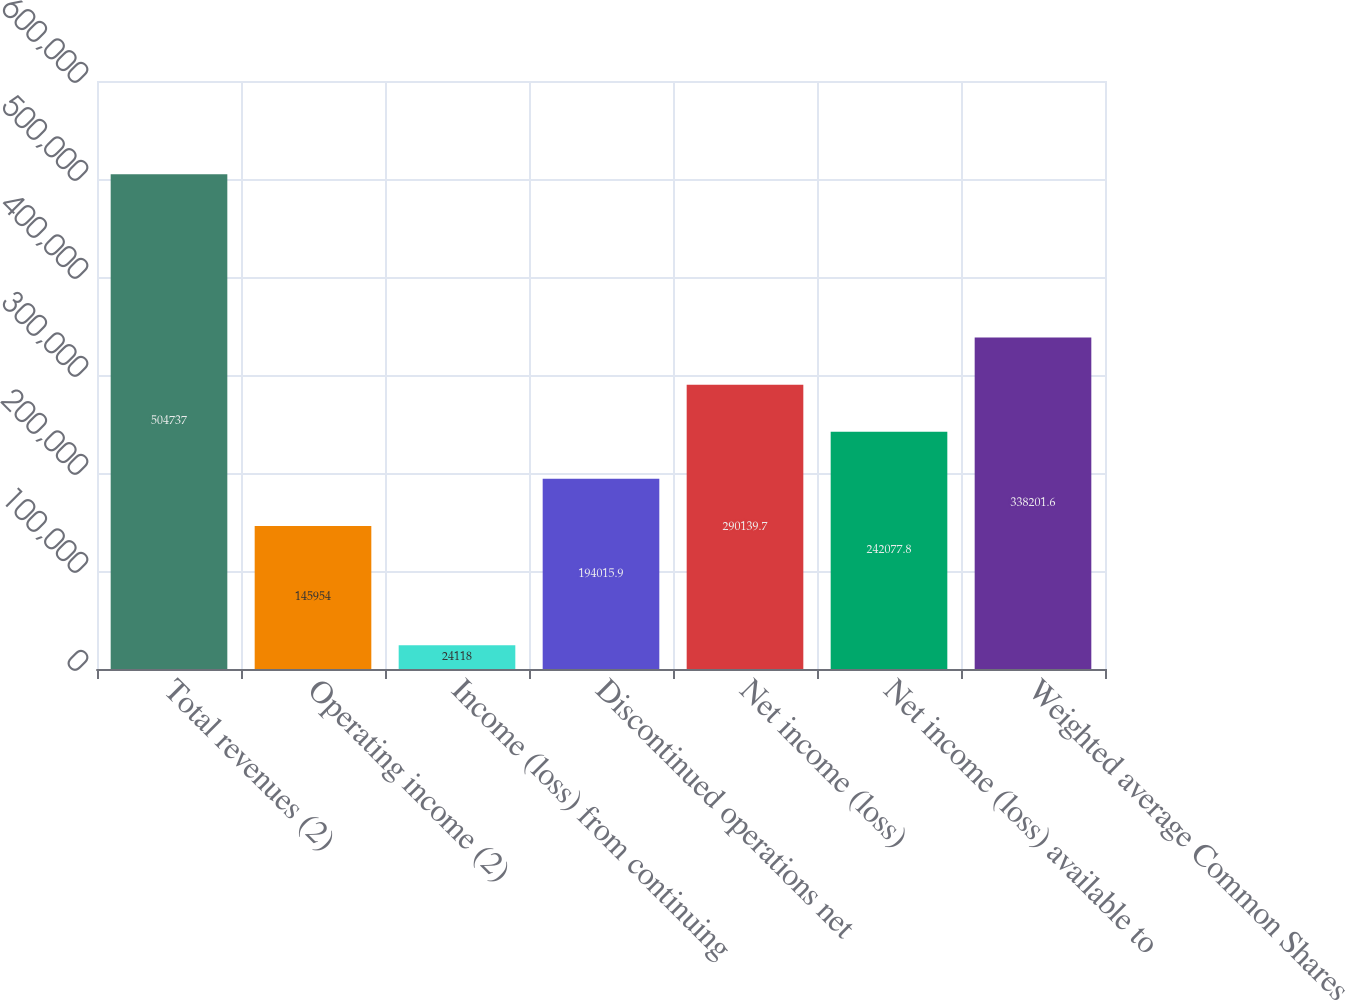Convert chart. <chart><loc_0><loc_0><loc_500><loc_500><bar_chart><fcel>Total revenues (2)<fcel>Operating income (2)<fcel>Income (loss) from continuing<fcel>Discontinued operations net<fcel>Net income (loss)<fcel>Net income (loss) available to<fcel>Weighted average Common Shares<nl><fcel>504737<fcel>145954<fcel>24118<fcel>194016<fcel>290140<fcel>242078<fcel>338202<nl></chart> 